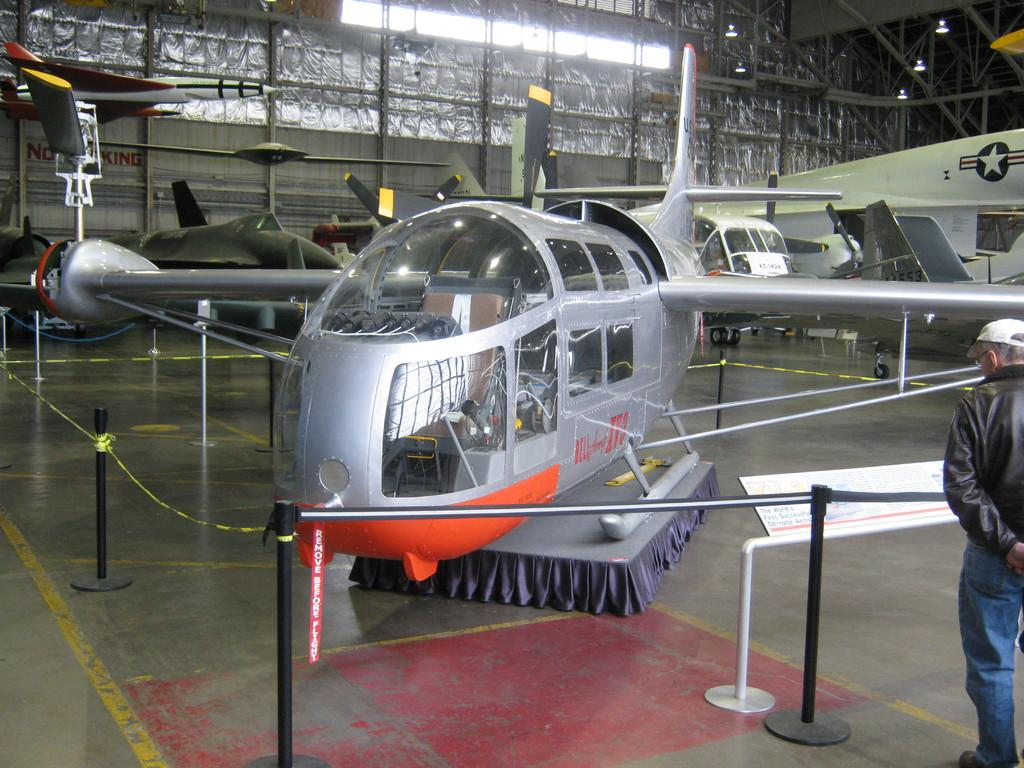What is the main subject of the image? The main subject of the image is planes. Can you describe the position of the planes in the image? The planes are between a caution rope. Are there any people visible in the image? Yes, there is a person visible in the image. What type of stone can be seen on the tray held by the person in the image? There is no tray or stone present in the image. What drink is the person holding in the image? There is no drink visible in the image. 